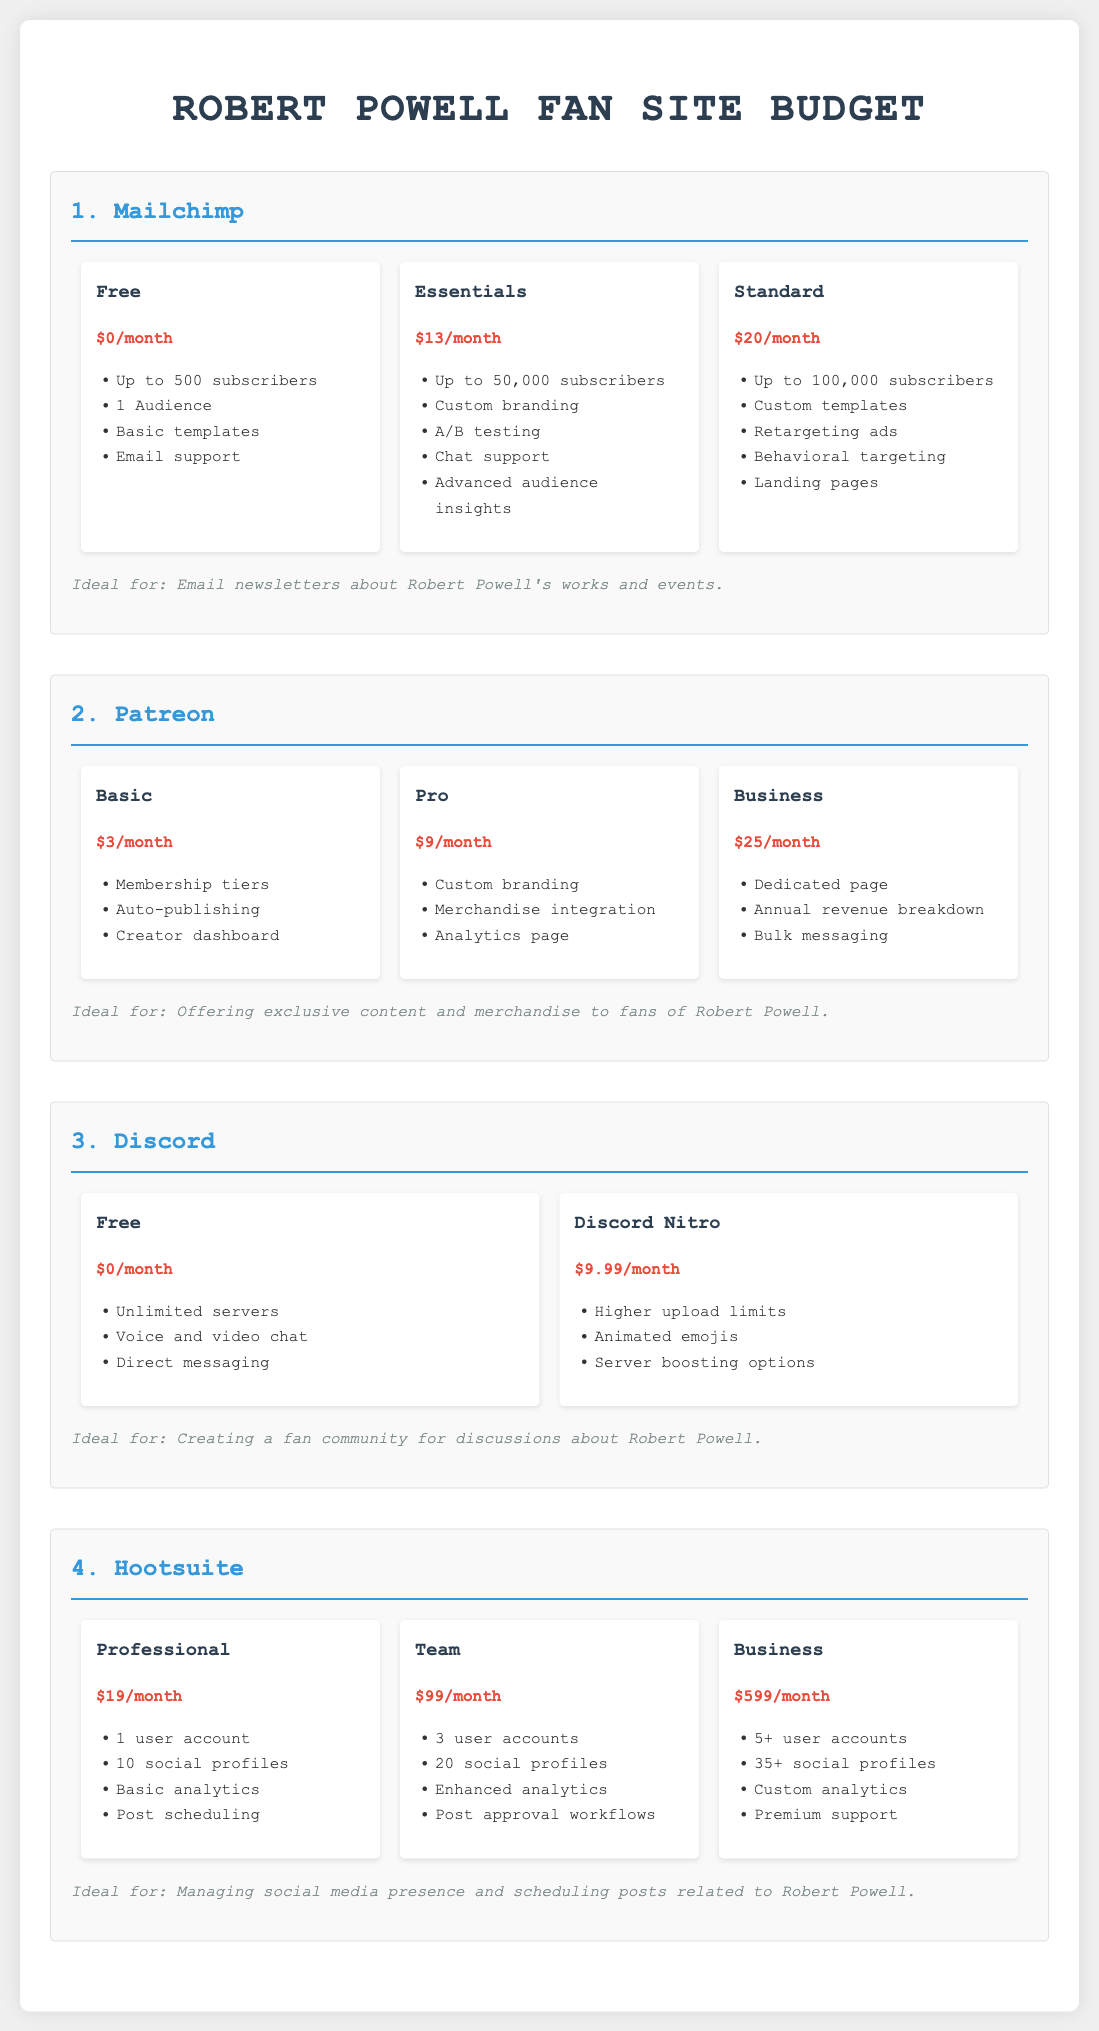What is the monthly cost of the Essentials plan for Mailchimp? The Essentials plan for Mailchimp costs $13 per month.
Answer: $13 How many subscribers does the Standard plan for Mailchimp support? The Standard plan for Mailchimp supports up to 100,000 subscribers.
Answer: 100,000 subscribers What is the lowest-cost subscription plan available on Patreon? The lowest-cost subscription plan on Patreon is the Basic plan at $3 per month.
Answer: $3 Which tool is listed as ideal for creating a fan community? Discord is listed as ideal for creating a fan community.
Answer: Discord What features are included in the Professional plan of Hootsuite? The Professional plan of Hootsuite includes 1 user account, 10 social profiles, basic analytics, and post scheduling.
Answer: 1 user account, 10 social profiles, basic analytics, post scheduling What is the total monthly cost of the Business plan for Patreon? The Business plan for Patreon costs $25 per month.
Answer: $25 What is the monthly cost of Discord Nitro? Discord Nitro costs $9.99 per month.
Answer: $9.99 How many social profiles can the Team plan of Hootsuite manage? The Team plan of Hootsuite can manage 20 social profiles.
Answer: 20 social profiles What features does the Basic plan of Patreon have? The Basic plan of Patreon includes membership tiers, auto-publishing, and a creator dashboard.
Answer: Membership tiers, auto-publishing, creator dashboard 